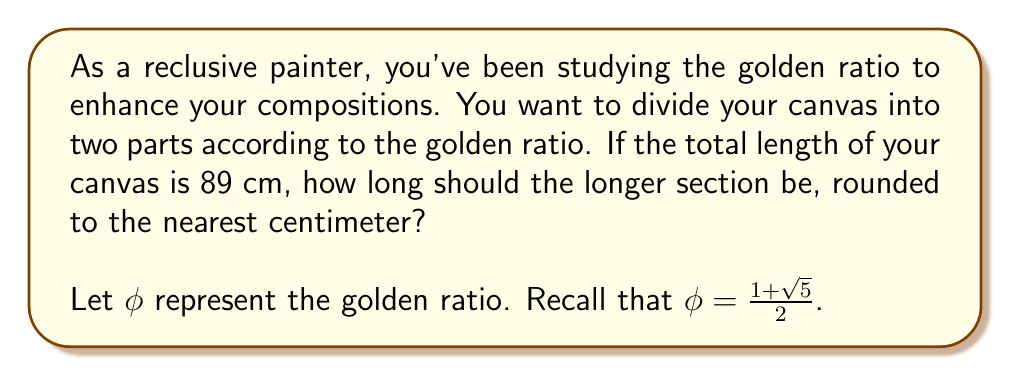Could you help me with this problem? To solve this problem, let's follow these steps:

1) First, recall the definition of the golden ratio:
   The ratio of the longer part to the shorter part is equal to the ratio of the whole to the longer part.

2) Let $x$ be the length of the longer section. Then $(89-x)$ is the length of the shorter section.

3) We can express this relationship mathematically as:

   $$\frac{x}{89-x} = \frac{89}{x} = \phi$$

4) We know that $\phi = \frac{1 + \sqrt{5}}{2}$. Let's substitute this:

   $$\frac{x}{89-x} = \frac{1 + \sqrt{5}}{2}$$

5) Cross multiply:

   $$2x = (89-x)(1 + \sqrt{5})$$

6) Expand the right side:

   $$2x = 89 + 89\sqrt{5} - x - x\sqrt{5}$$

7) Rearrange terms:

   $$2x + x + x\sqrt{5} = 89 + 89\sqrt{5}$$
   $$x(3 + \sqrt{5}) = 89(1 + \sqrt{5})$$

8) Divide both sides by $(3 + \sqrt{5})$:

   $$x = \frac{89(1 + \sqrt{5})}{3 + \sqrt{5}}$$

9) Multiply numerator and denominator by $(3 - \sqrt{5})$ to rationalize the denominator:

   $$x = \frac{89(1 + \sqrt{5})(3 - \sqrt{5})}{(3 + \sqrt{5})(3 - \sqrt{5})} = \frac{89(3 - \sqrt{5} + 3\sqrt{5} - 5)}{9 - 5} = \frac{89(3 + 2\sqrt{5} - 5)}{4} = \frac{89(-2 + 2\sqrt{5})}{4}$$

10) Simplify:

    $$x = \frac{89(-2 + 2\sqrt{5})}{4} = \frac{-178 + 178\sqrt{5}}{4} = -44.5 + 44.5\sqrt{5} \approx 55.0167$$

11) Rounding to the nearest centimeter:

    $$x \approx 55 \text{ cm}$$
Answer: 55 cm 